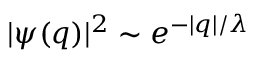Convert formula to latex. <formula><loc_0><loc_0><loc_500><loc_500>| \psi ( q ) | ^ { 2 } \sim e ^ { - | q | / \lambda }</formula> 